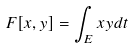<formula> <loc_0><loc_0><loc_500><loc_500>F [ x , y ] = \int _ { E } x y d t</formula> 